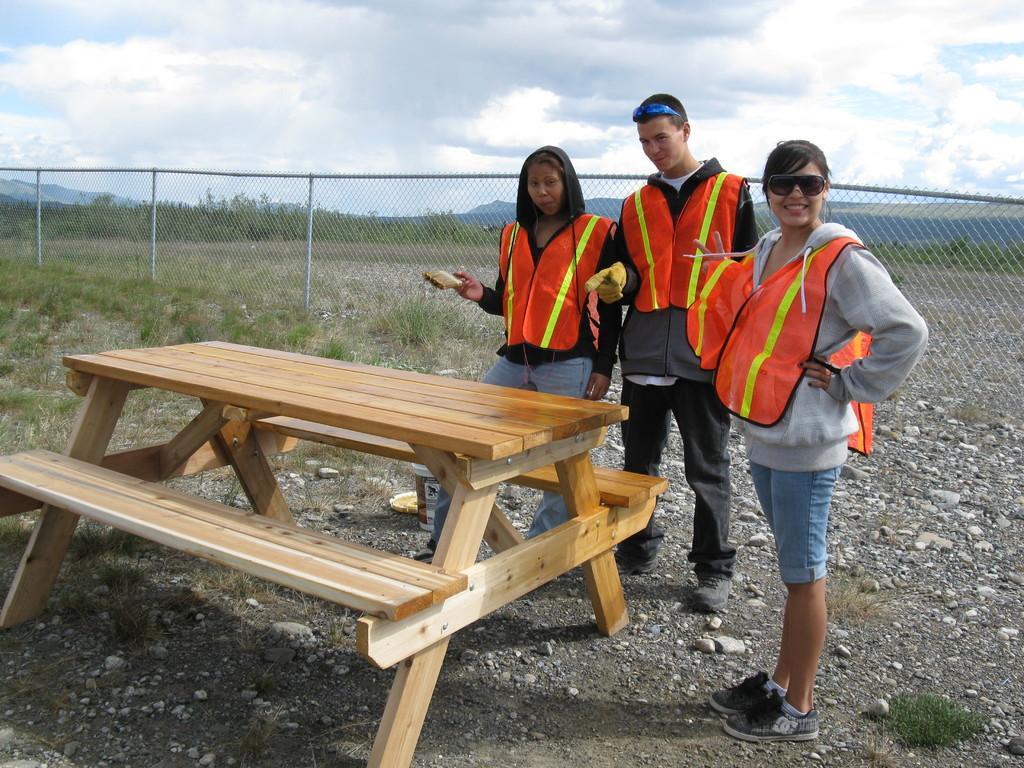How would you summarize this image in a sentence or two? In this image we have a group of people who are standing and wearing a jacket. There are two women and a man. Behind these people we have a fence and beside the people we have a bench of wooden, On the top right of the image we have blue sky. 